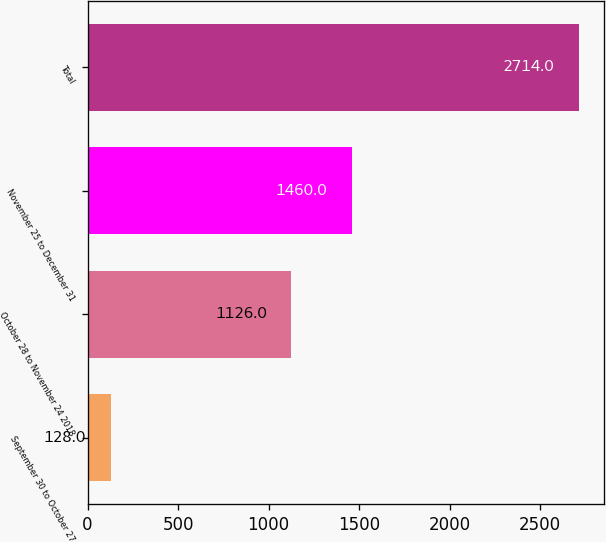Convert chart to OTSL. <chart><loc_0><loc_0><loc_500><loc_500><bar_chart><fcel>September 30 to October 27<fcel>October 28 to November 24 2018<fcel>November 25 to December 31<fcel>Total<nl><fcel>128<fcel>1126<fcel>1460<fcel>2714<nl></chart> 